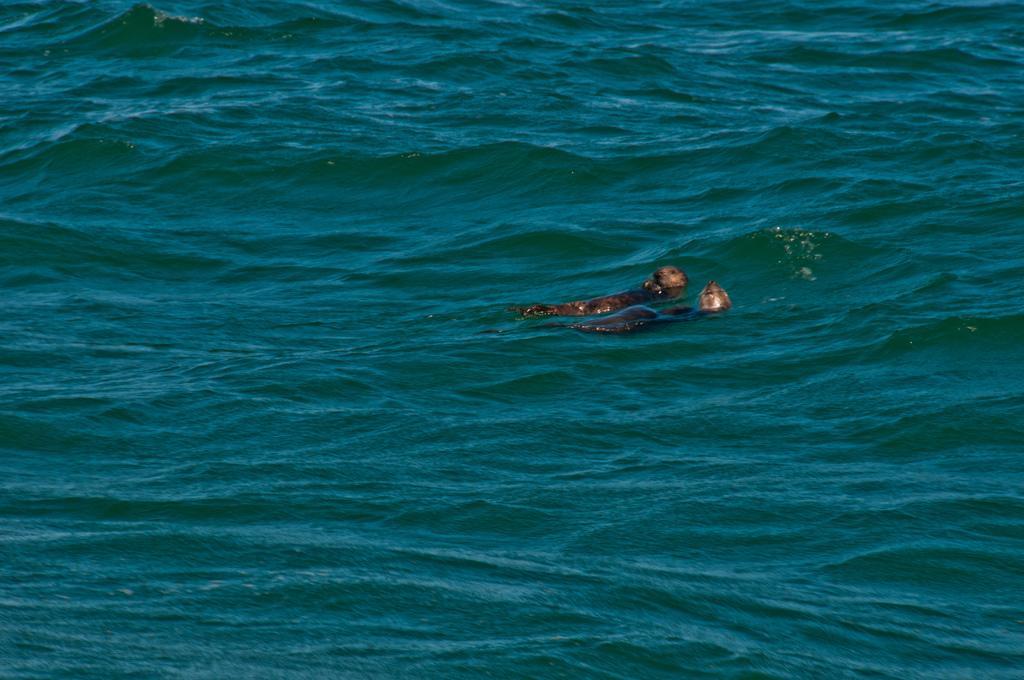How would you summarize this image in a sentence or two? In this image there are two seals in the water. 